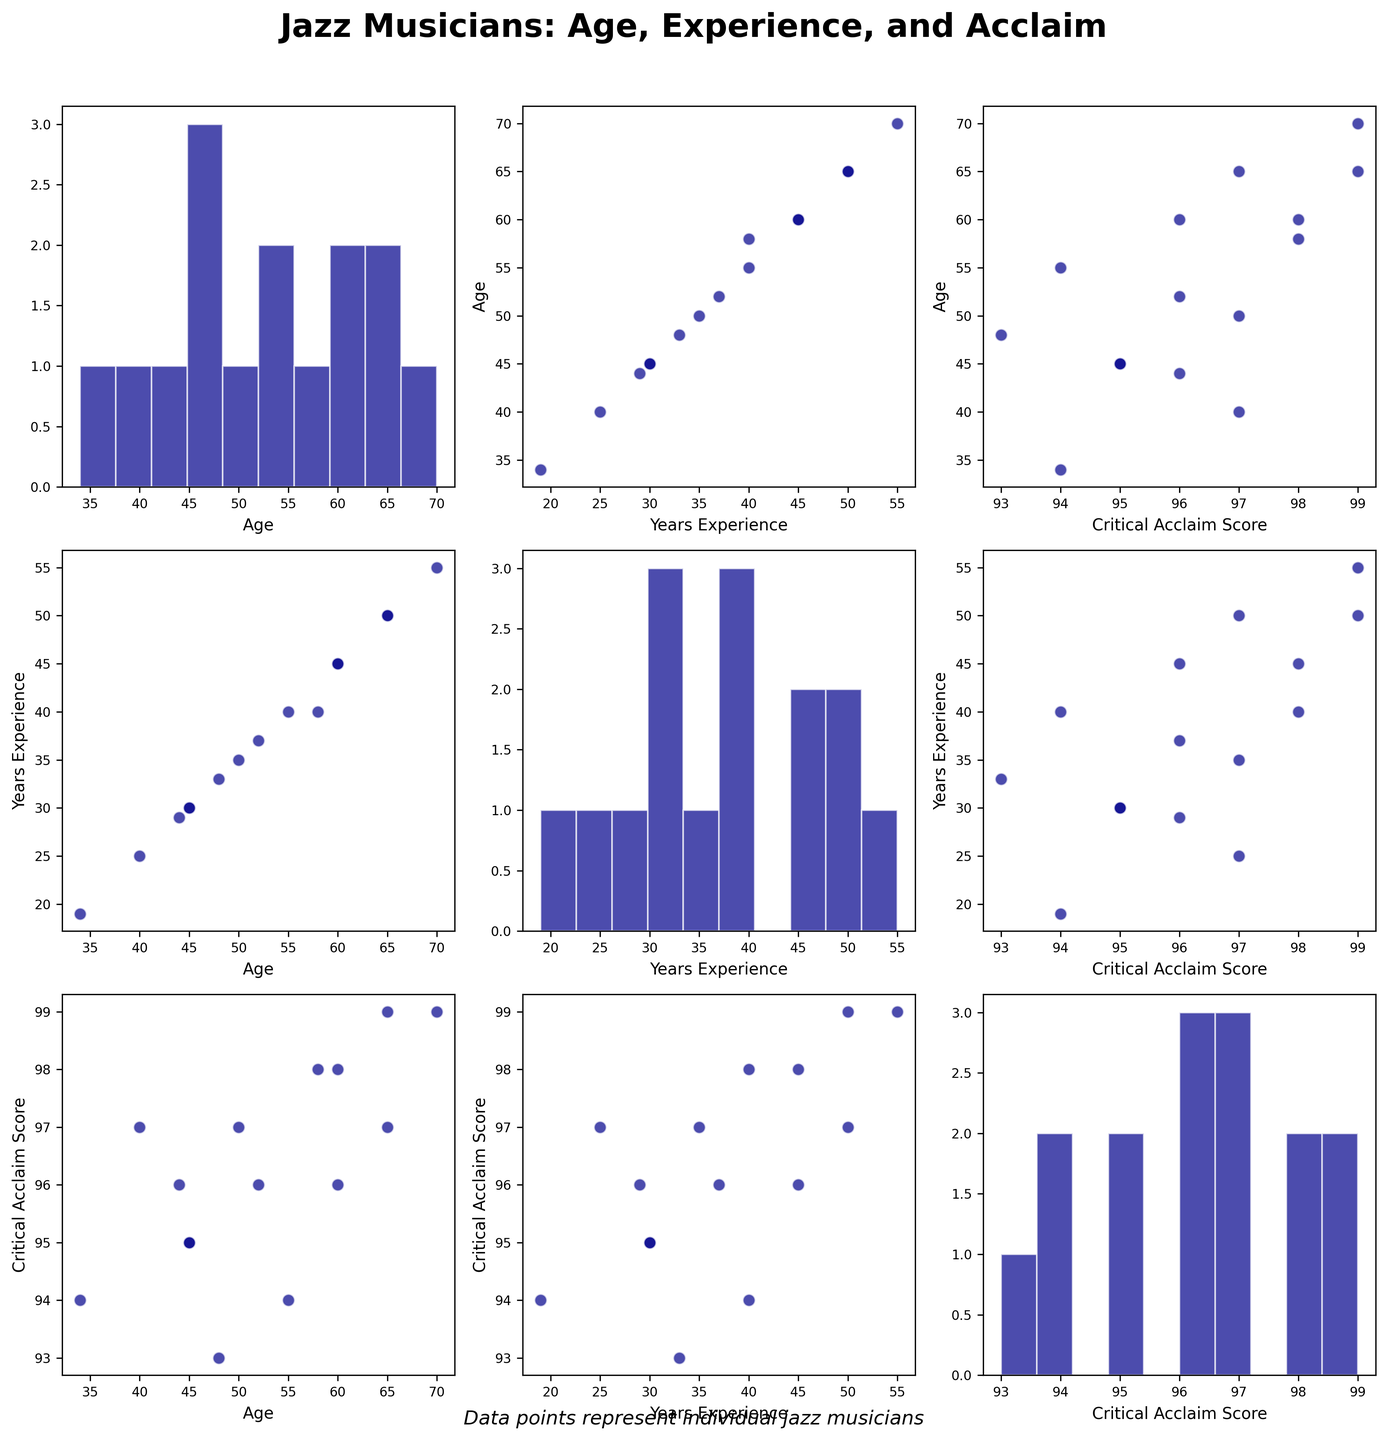What's the title of the figure? The title is usually placed at the top of the figure. In this case, it says "Jazz Musicians: Age, Experience, and Acclaim" in bold, which is appropriate given the context of the data.
Answer: Jazz Musicians: Age, Experience, and Acclaim How are outlier points visually indicated in the scatterplots? Outliers stand out because they are points that are significantly further away from the other points. If there were outliers, they would be very easy to spot as distant isolated points in the scatterplots.
Answer: They are distant isolated points What range of Critical Acclaim Scores is observed in the histogram? By examining the histogram for Critical Acclaim Scores, we can see the distribution of values. Visual inspection shows the scores are within the 90 to 100 range, as indicated by the bin counts.
Answer: 90 to 100 Is there any visible correlation between Age and Years of Experience? Look at the scatterplot in the cell where the x-axis is Age and the y-axis is Years of Experience. The data points seem to form a somewhat linear pattern, suggesting that older musicians tend to have more years of experience.
Answer: Yes, there is a positive correlation Which axis holds the label "Years Experience" in the bottom right scatterplot? In the scatterplot matrix, the bottom-right scatterplot's x-axis corresponds to the final column in the matrix, which is "Critical Acclaim Score," while the y-axis label corresponds to "Years of Experience"
Answer: y-axis Is the relationship between Years of Experience and Critical Acclaim Score direct or inverse? By looking at the scatterplot where the x-axis is Years of Experience and the y-axis is Critical Acclaim Score, observe if the trend is going upward (direct relationship) or downward (inverse relationship). The points suggest there is no strong clear relationship.
Answer: No clear relationship What is the distribution shape of Jazz Musicians' Age? Check the histogram for Age. The shape will indicate whether the data is normally distributed, skewed, or has any other pattern. It appears fairly normally distributed around a central point with a slight skew towards older ages.
Answer: Slightly skewed toward older ages Do any musicians have identical Critical Acclaim Scores? A close observation of the data points in the scatterplot with both axes labeled as "Critical Acclaim Score" should reveal if any of them align perfectly, indicating identical scores. Some musicians indeed have identical scores as shown by overlying points.
Answer: Yes, some have identical scores How many data points are there in total? Each scatterplot matrix cell shows several data points. By counting the points in any given scatterplot, we observe that there are 15 data points representing the individual musicians.
Answer: 15 Which axis in the scatterplot matrix cells does not change its position? In scatterplot matrices, the diagonal cells typically feature histograms of a single variable while the other cells show scatterplots of pairwise variables. In this figure, the labels in the diagonal cells show the variable itself (Age, Years of Experience, and Critical Acclaim Score), and these labels do not change.
Answer: Diagonal cells 